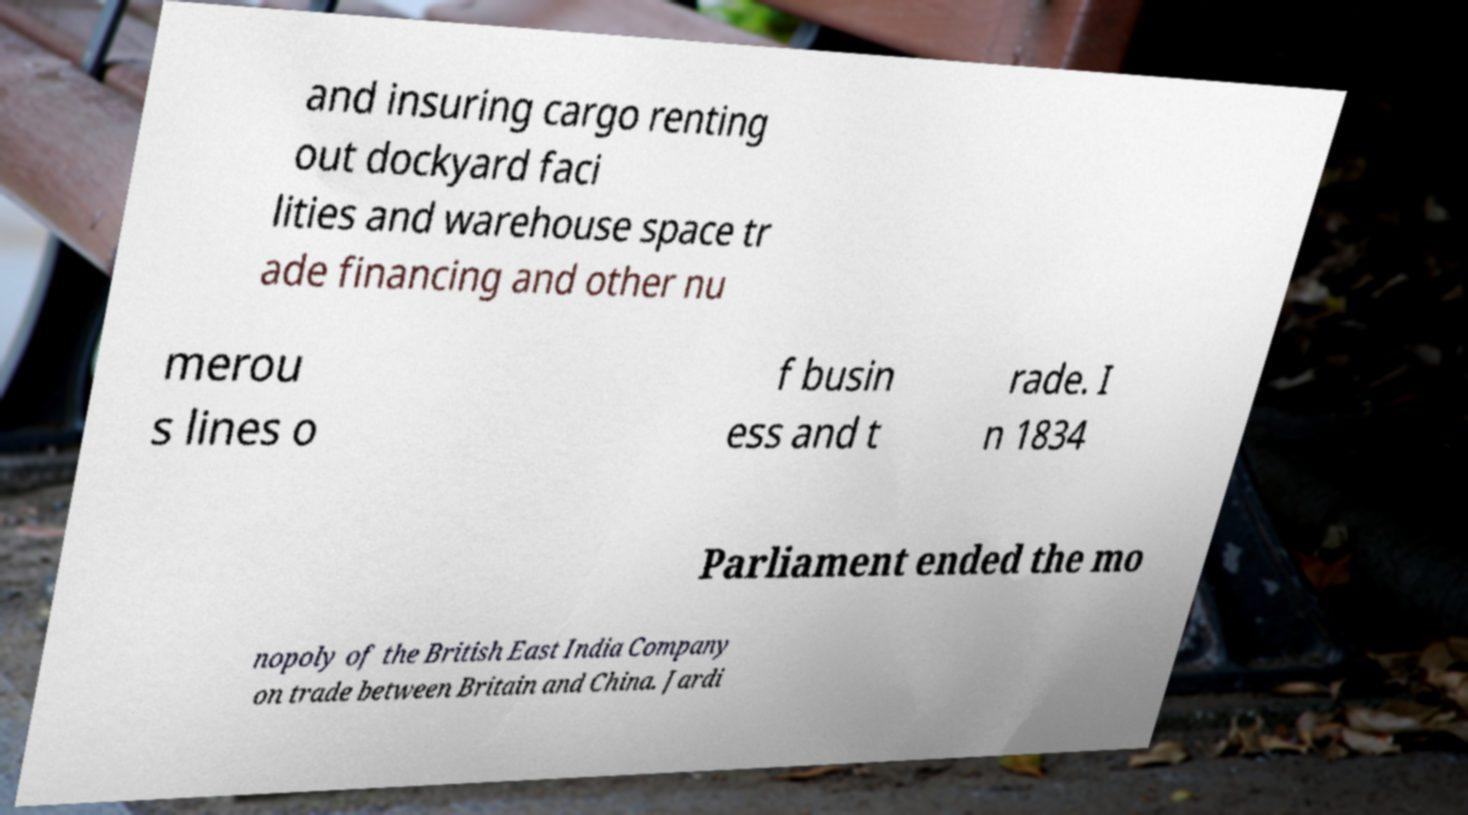Please identify and transcribe the text found in this image. and insuring cargo renting out dockyard faci lities and warehouse space tr ade financing and other nu merou s lines o f busin ess and t rade. I n 1834 Parliament ended the mo nopoly of the British East India Company on trade between Britain and China. Jardi 